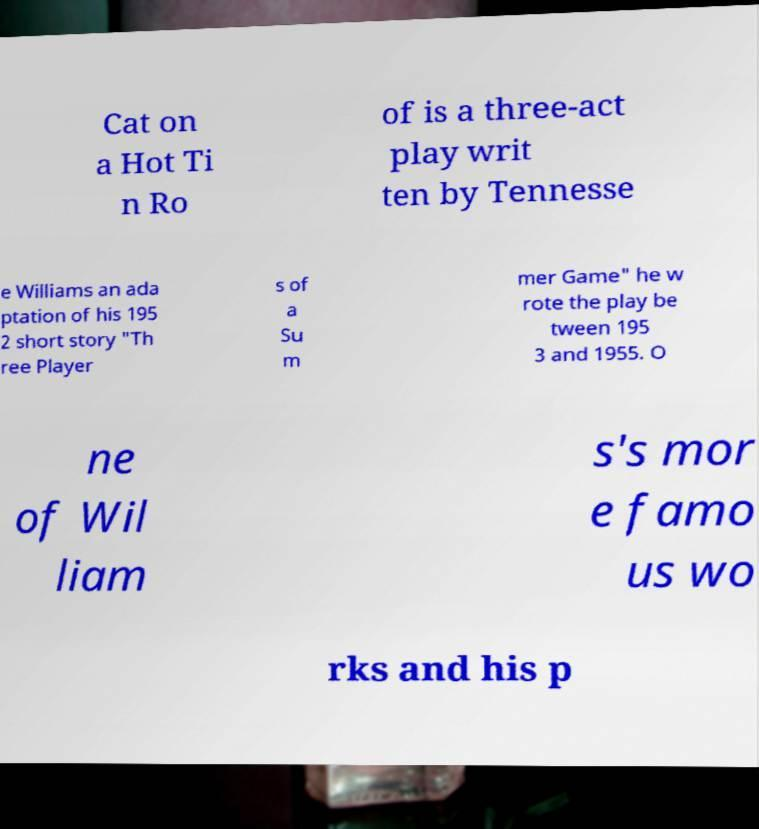Could you assist in decoding the text presented in this image and type it out clearly? Cat on a Hot Ti n Ro of is a three-act play writ ten by Tennesse e Williams an ada ptation of his 195 2 short story "Th ree Player s of a Su m mer Game" he w rote the play be tween 195 3 and 1955. O ne of Wil liam s's mor e famo us wo rks and his p 